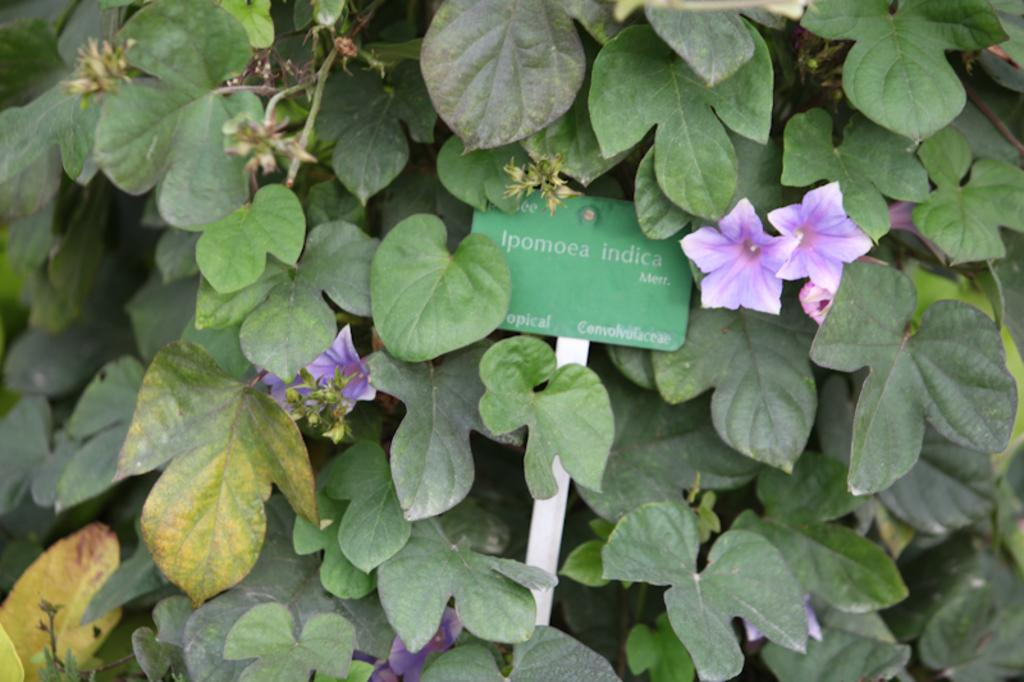What type of living organisms can be seen in the image? There are flowers in the image. What do the flowers belong to? The flowers belong to a plant. What is the color of the text board in the image? The text board in the image is green. What color are the stickers on the text board? The stickers on the text board are white. What type of soup is being served in the bucket in the image? There is no bucket or soup present in the image. Can you describe the zipper on the plant in the image? There is no zipper on the plant or any other part of the image. 